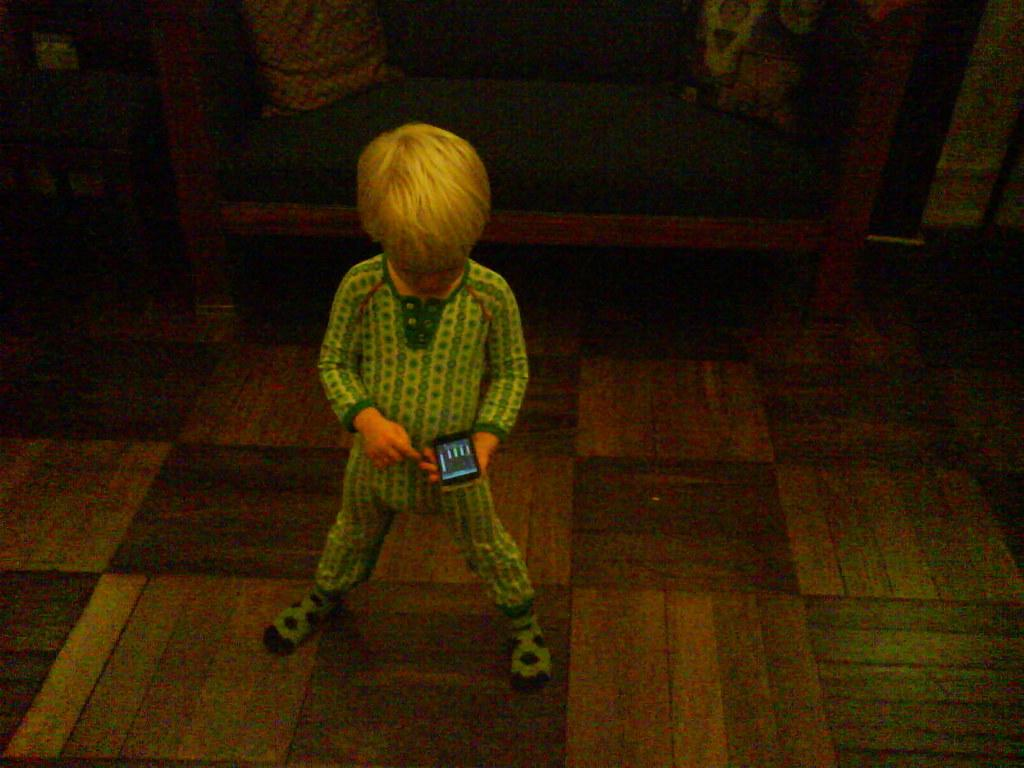What is the main subject of the image? The main subject of the image is a child. What is the child wearing? The child is wearing a green dress. What is the child holding in the image? The child is holding a mobile with one hand. What is the child standing on? The child is standing on a floor. How would you describe the background of the image? The background of the image is dark in color. How does the child show respect to the calculator in the image? There is no calculator present in the image, so the child cannot show respect to it. 